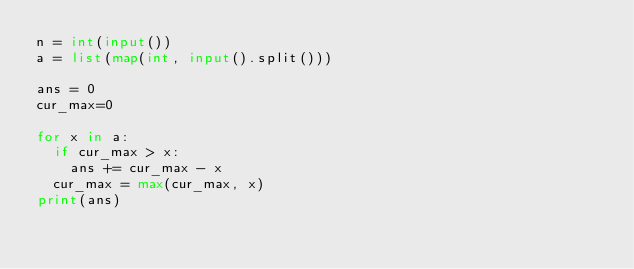<code> <loc_0><loc_0><loc_500><loc_500><_Python_>n = int(input())
a = list(map(int, input().split()))

ans = 0
cur_max=0

for x in a:
  if cur_max > x:
    ans += cur_max - x
  cur_max = max(cur_max, x)
print(ans)</code> 